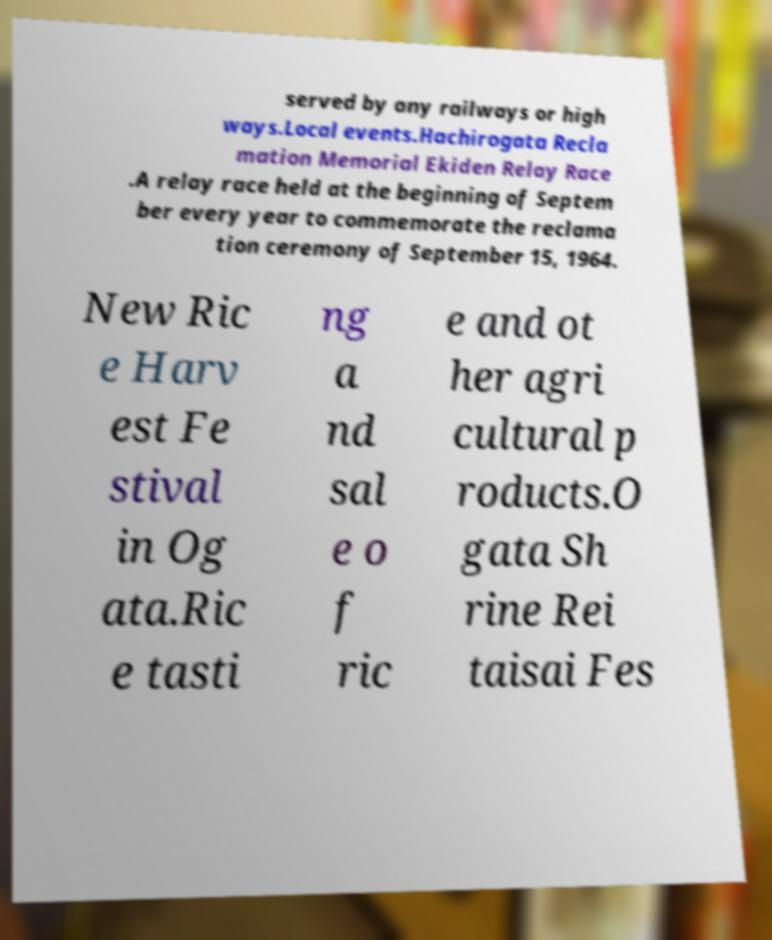Please read and relay the text visible in this image. What does it say? served by any railways or high ways.Local events.Hachirogata Recla mation Memorial Ekiden Relay Race .A relay race held at the beginning of Septem ber every year to commemorate the reclama tion ceremony of September 15, 1964. New Ric e Harv est Fe stival in Og ata.Ric e tasti ng a nd sal e o f ric e and ot her agri cultural p roducts.O gata Sh rine Rei taisai Fes 